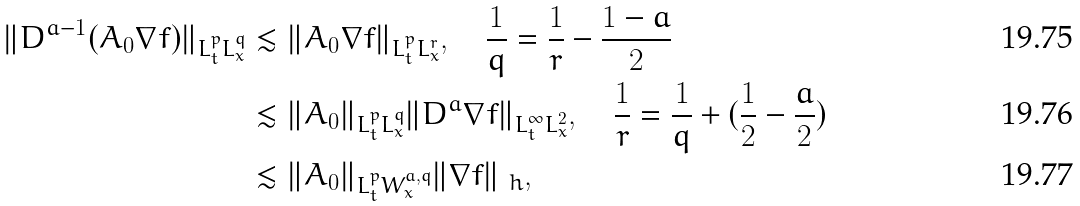<formula> <loc_0><loc_0><loc_500><loc_500>\| D ^ { a - 1 } ( A _ { 0 } \nabla f ) \| _ { L ^ { p } _ { t } L ^ { q } _ { x } } & \lesssim \| A _ { 0 } \nabla f \| _ { L ^ { p } _ { t } L ^ { r } _ { x } } , \quad \frac { 1 } { q } = \frac { 1 } { r } - \frac { 1 - a } { 2 } \\ & \lesssim \| A _ { 0 } \| _ { L ^ { p } _ { t } L ^ { q } _ { x } } \| D ^ { a } \nabla f \| _ { L ^ { \infty } _ { t } L ^ { 2 } _ { x } } , \quad \frac { 1 } { r } = \frac { 1 } { q } + ( \frac { 1 } { 2 } - \frac { a } { 2 } ) \\ & \lesssim \| A _ { 0 } \| _ { L ^ { p } _ { t } W ^ { a , q } _ { x } } \| \nabla f \| _ { \ h } ,</formula> 